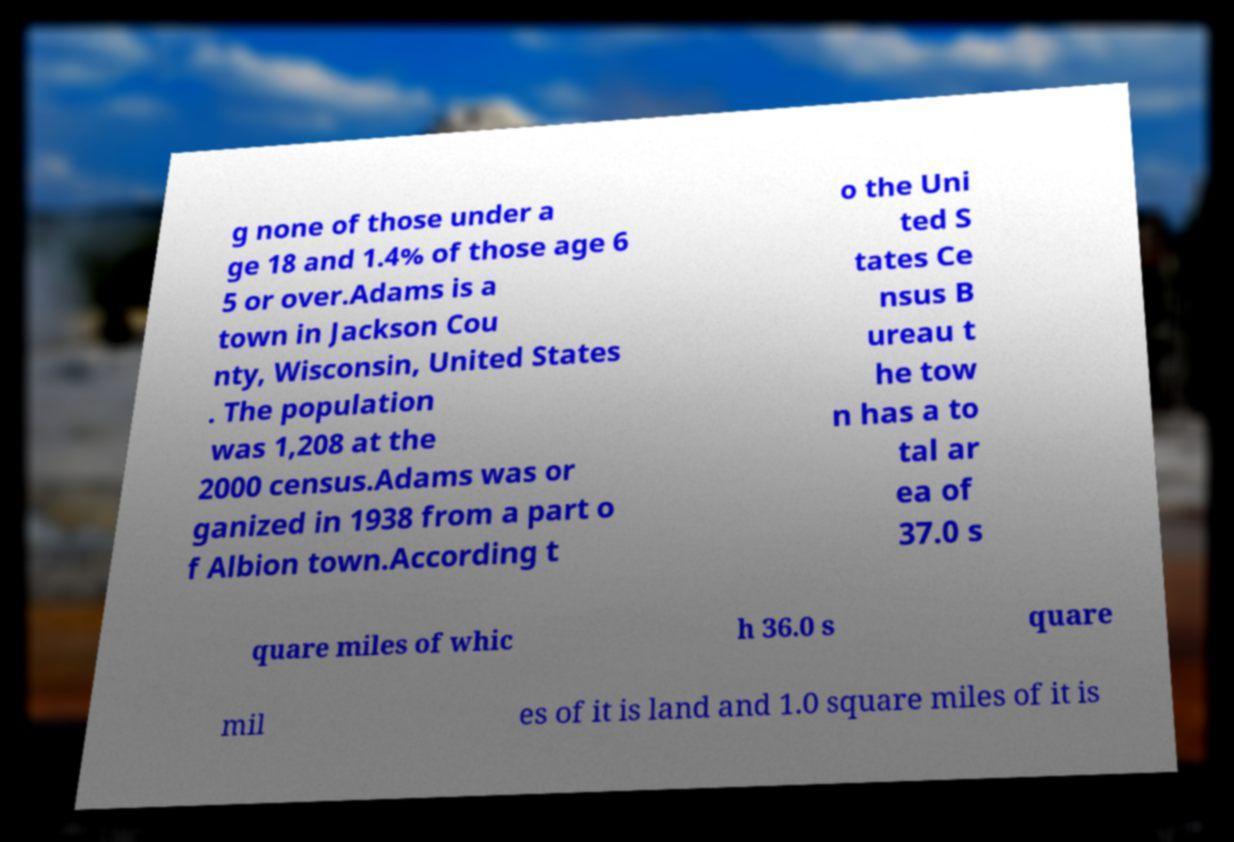Could you assist in decoding the text presented in this image and type it out clearly? g none of those under a ge 18 and 1.4% of those age 6 5 or over.Adams is a town in Jackson Cou nty, Wisconsin, United States . The population was 1,208 at the 2000 census.Adams was or ganized in 1938 from a part o f Albion town.According t o the Uni ted S tates Ce nsus B ureau t he tow n has a to tal ar ea of 37.0 s quare miles of whic h 36.0 s quare mil es of it is land and 1.0 square miles of it is 